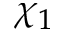<formula> <loc_0><loc_0><loc_500><loc_500>\chi _ { 1 }</formula> 